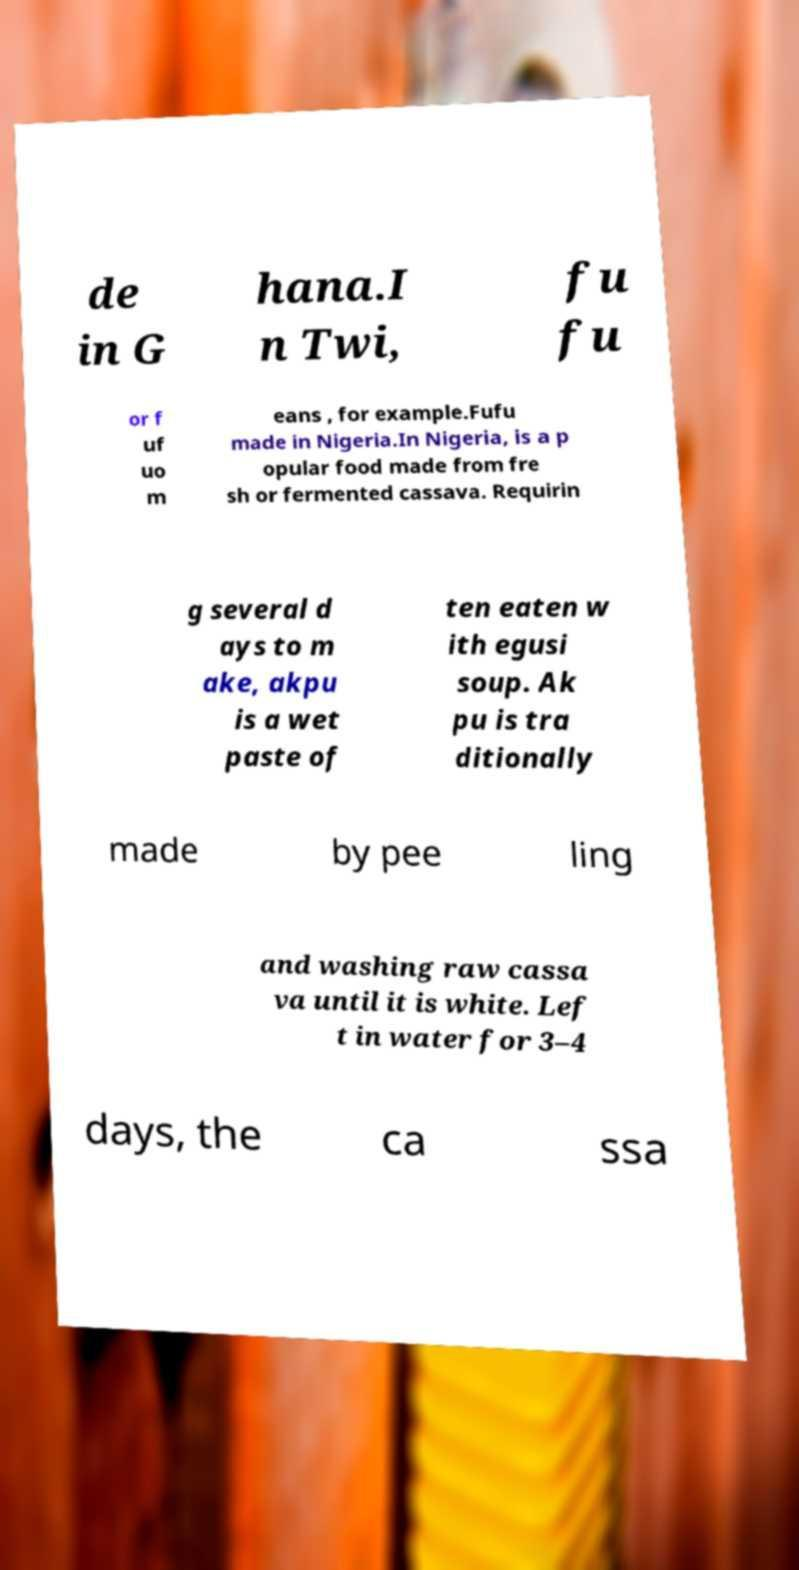Please identify and transcribe the text found in this image. de in G hana.I n Twi, fu fu or f uf uo m eans , for example.Fufu made in Nigeria.In Nigeria, is a p opular food made from fre sh or fermented cassava. Requirin g several d ays to m ake, akpu is a wet paste of ten eaten w ith egusi soup. Ak pu is tra ditionally made by pee ling and washing raw cassa va until it is white. Lef t in water for 3–4 days, the ca ssa 